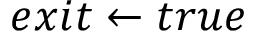Convert formula to latex. <formula><loc_0><loc_0><loc_500><loc_500>e x i t \gets t r u e</formula> 